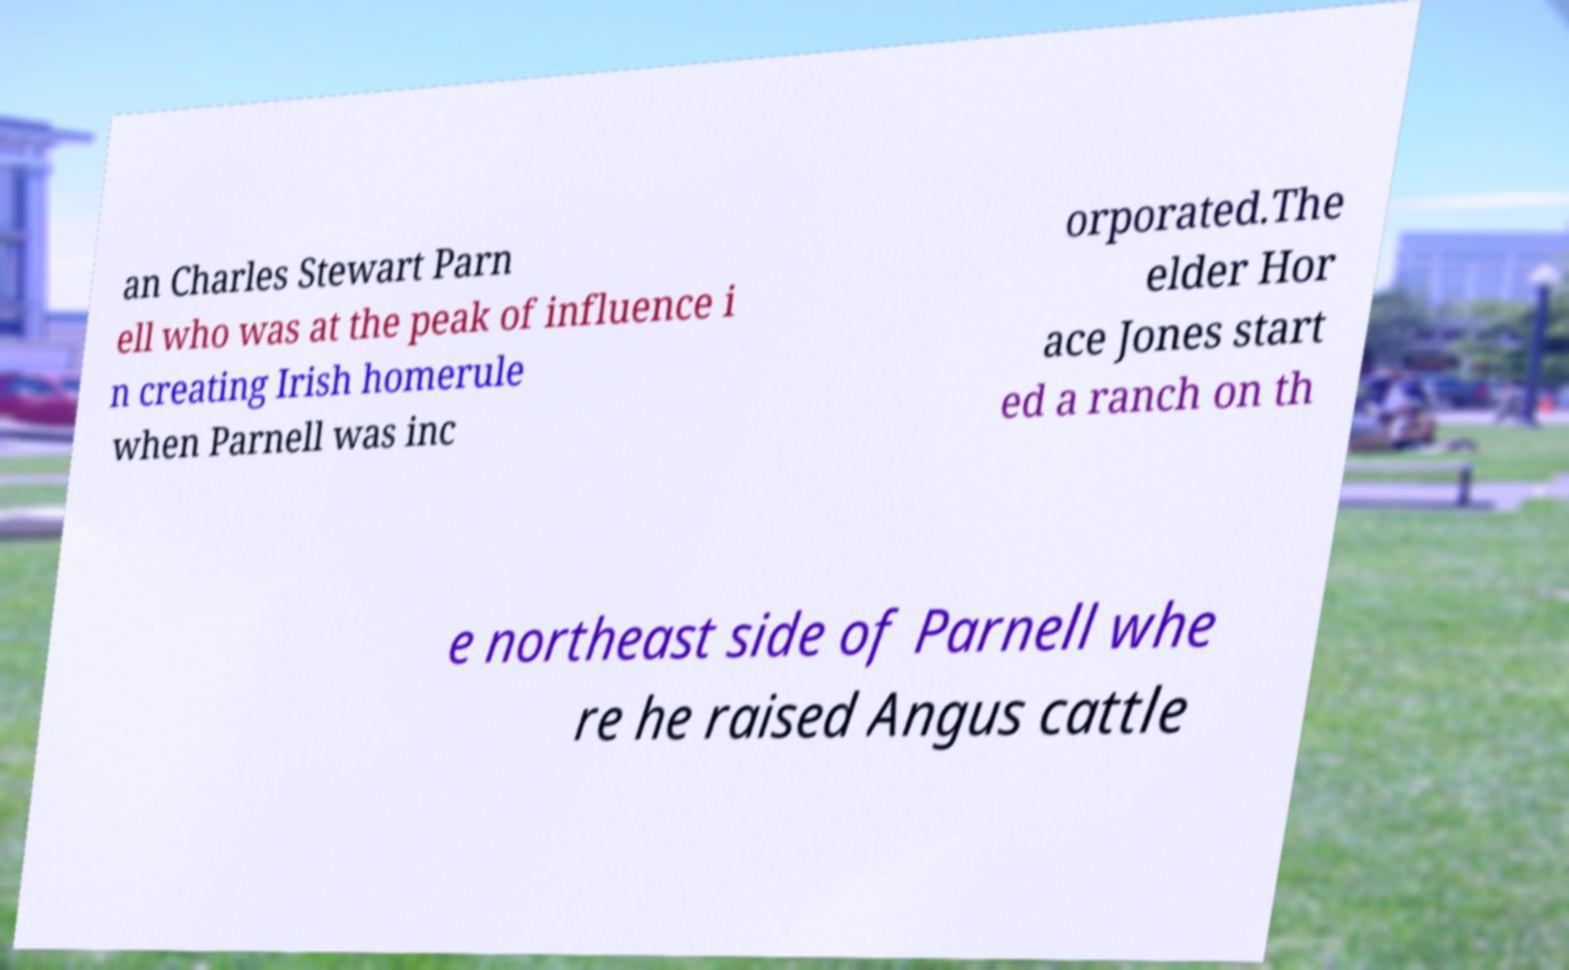Can you read and provide the text displayed in the image?This photo seems to have some interesting text. Can you extract and type it out for me? an Charles Stewart Parn ell who was at the peak of influence i n creating Irish homerule when Parnell was inc orporated.The elder Hor ace Jones start ed a ranch on th e northeast side of Parnell whe re he raised Angus cattle 